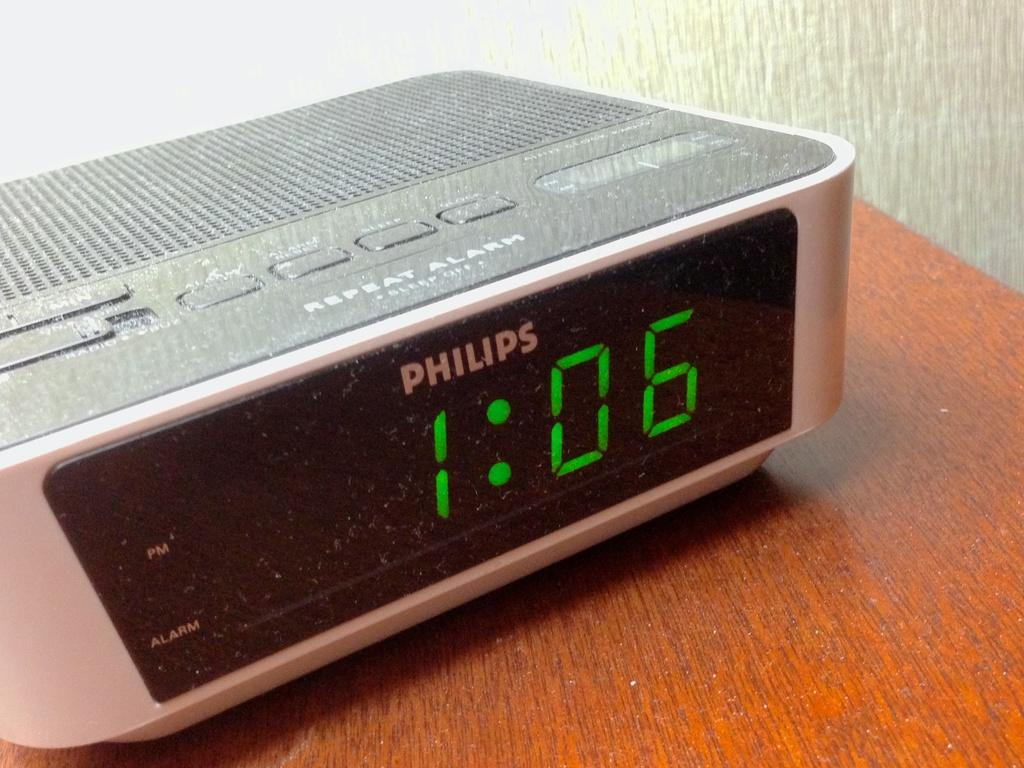<image>
Render a clear and concise summary of the photo. A Philips digital clock showing the time as 1:06. 